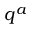Convert formula to latex. <formula><loc_0><loc_0><loc_500><loc_500>q ^ { a }</formula> 